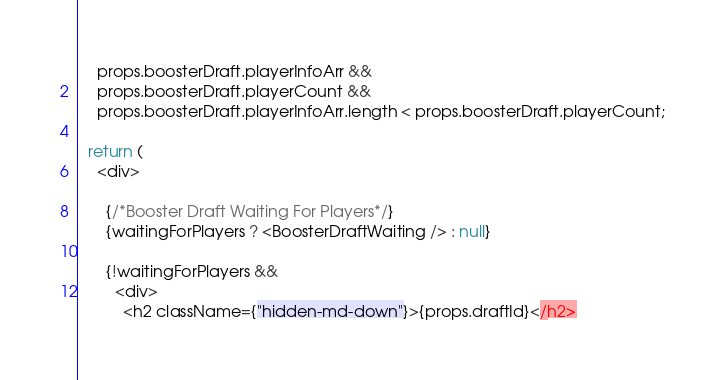<code> <loc_0><loc_0><loc_500><loc_500><_JavaScript_>    props.boosterDraft.playerInfoArr &&
    props.boosterDraft.playerCount &&
    props.boosterDraft.playerInfoArr.length < props.boosterDraft.playerCount;

  return (
    <div>

      {/*Booster Draft Waiting For Players*/}
      {waitingForPlayers ? <BoosterDraftWaiting /> : null}

      {!waitingForPlayers &&
        <div>
          <h2 className={"hidden-md-down"}>{props.draftId}</h2></code> 